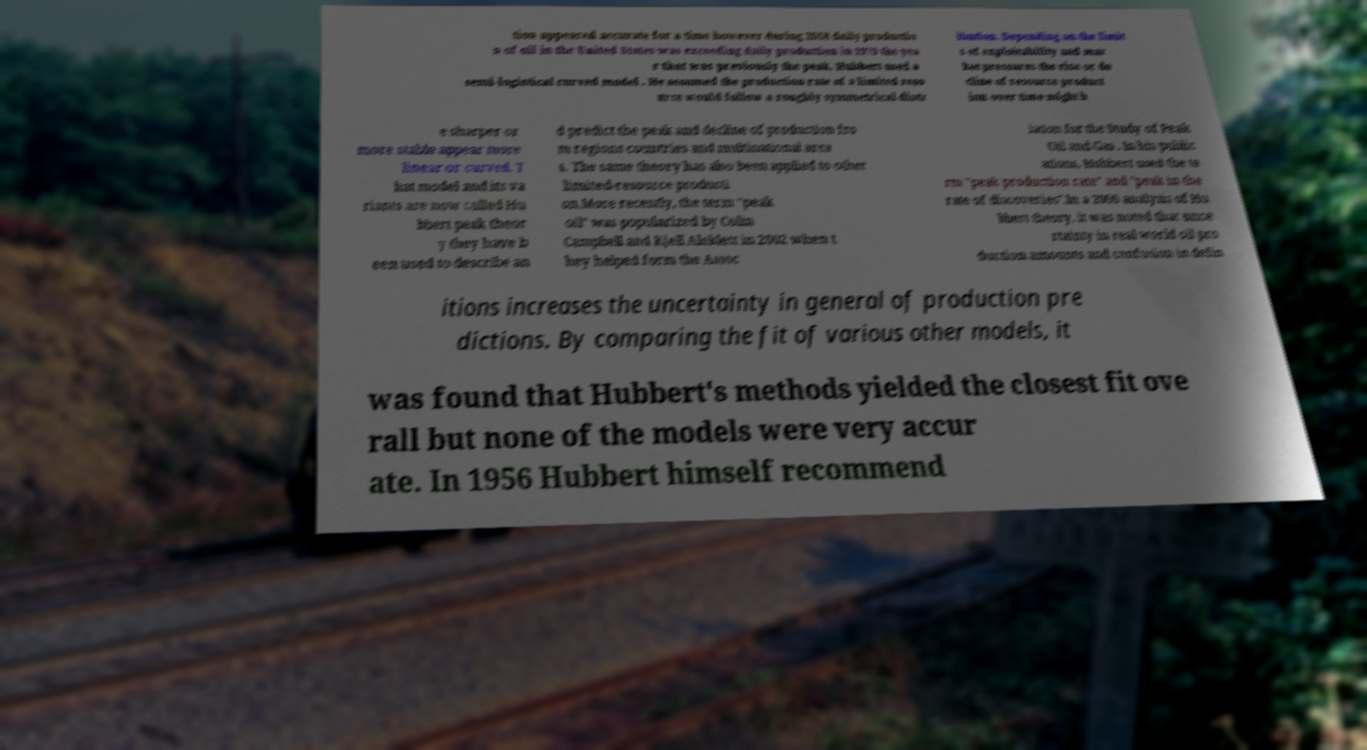Can you accurately transcribe the text from the provided image for me? tion appeared accurate for a time however during 2018 daily productio n of oil in the United States was exceeding daily production in 1970 the yea r that was previously the peak. Hubbert used a semi-logistical curved model . He assumed the production rate of a limited reso urce would follow a roughly symmetrical distr ibution. Depending on the limit s of exploitability and mar ket pressures the rise or de cline of resource product ion over time might b e sharper or more stable appear more linear or curved. T hat model and its va riants are now called Hu bbert peak theor y they have b een used to describe an d predict the peak and decline of production fro m regions countries and multinational area s. The same theory has also been applied to other limited-resource producti on.More recently, the term "peak oil" was popularized by Colin Campbell and Kjell Aleklett in 2002 when t hey helped form the Assoc iation for the Study of Peak Oil and Gas . In his public ations, Hubbert used the te rm "peak production rate" and "peak in the rate of discoveries".In a 2006 analysis of Hu bbert theory, it was noted that unce rtainty in real world oil pro duction amounts and confusion in defin itions increases the uncertainty in general of production pre dictions. By comparing the fit of various other models, it was found that Hubbert's methods yielded the closest fit ove rall but none of the models were very accur ate. In 1956 Hubbert himself recommend 